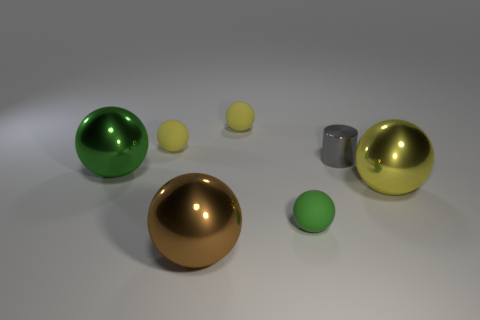Subtract all yellow balls. How many were subtracted if there are1yellow balls left? 2 Subtract all yellow cylinders. How many green balls are left? 2 Subtract 2 balls. How many balls are left? 4 Subtract all brown spheres. How many spheres are left? 5 Subtract all yellow rubber balls. How many balls are left? 4 Add 3 cylinders. How many objects exist? 10 Subtract all purple balls. Subtract all brown blocks. How many balls are left? 6 Subtract all cylinders. How many objects are left? 6 Subtract all big green shiny balls. Subtract all small green balls. How many objects are left? 5 Add 7 large yellow metal things. How many large yellow metal things are left? 8 